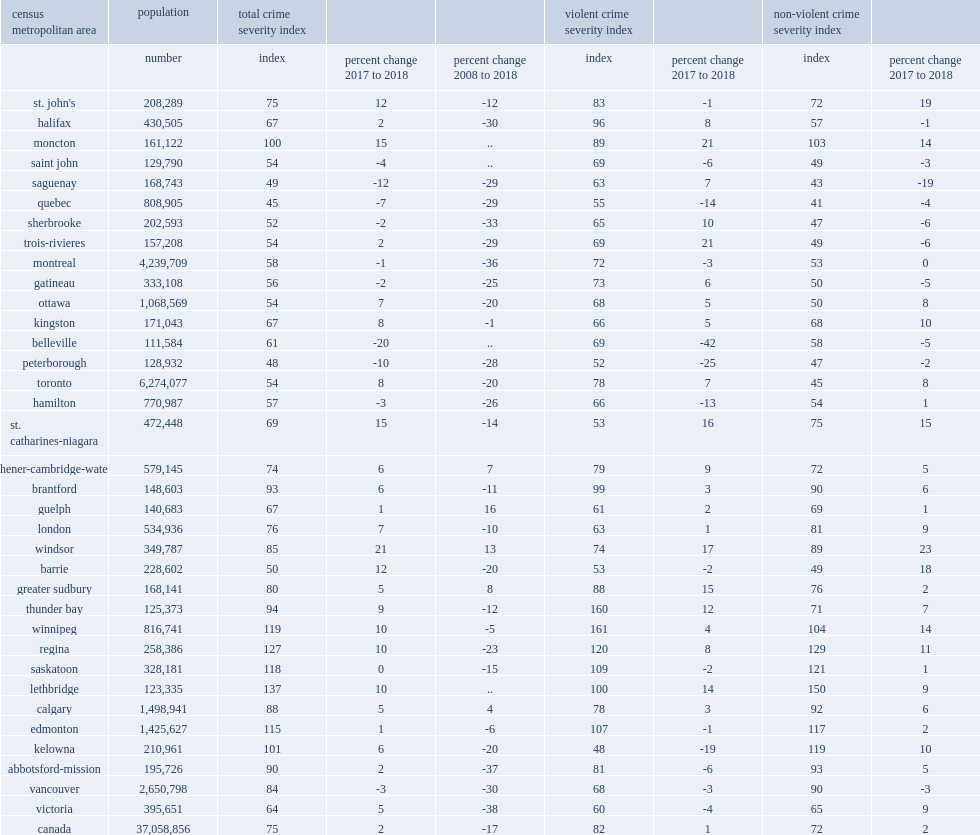What was the largest increases in vcsis were reported in moncton? 21.0. What was the increases in vcsis were reported in trois-rivieres? 21.0. What was the increases in vcsis were reported in windsor? 17.0. What was the increases in vcsis were reported in st. catharines-niagara? 16.0. What was the increases in vcsis were reported in greater sudbury? 15.0. What was the increases in vcsis were reported in lethbridge? 14.0. 